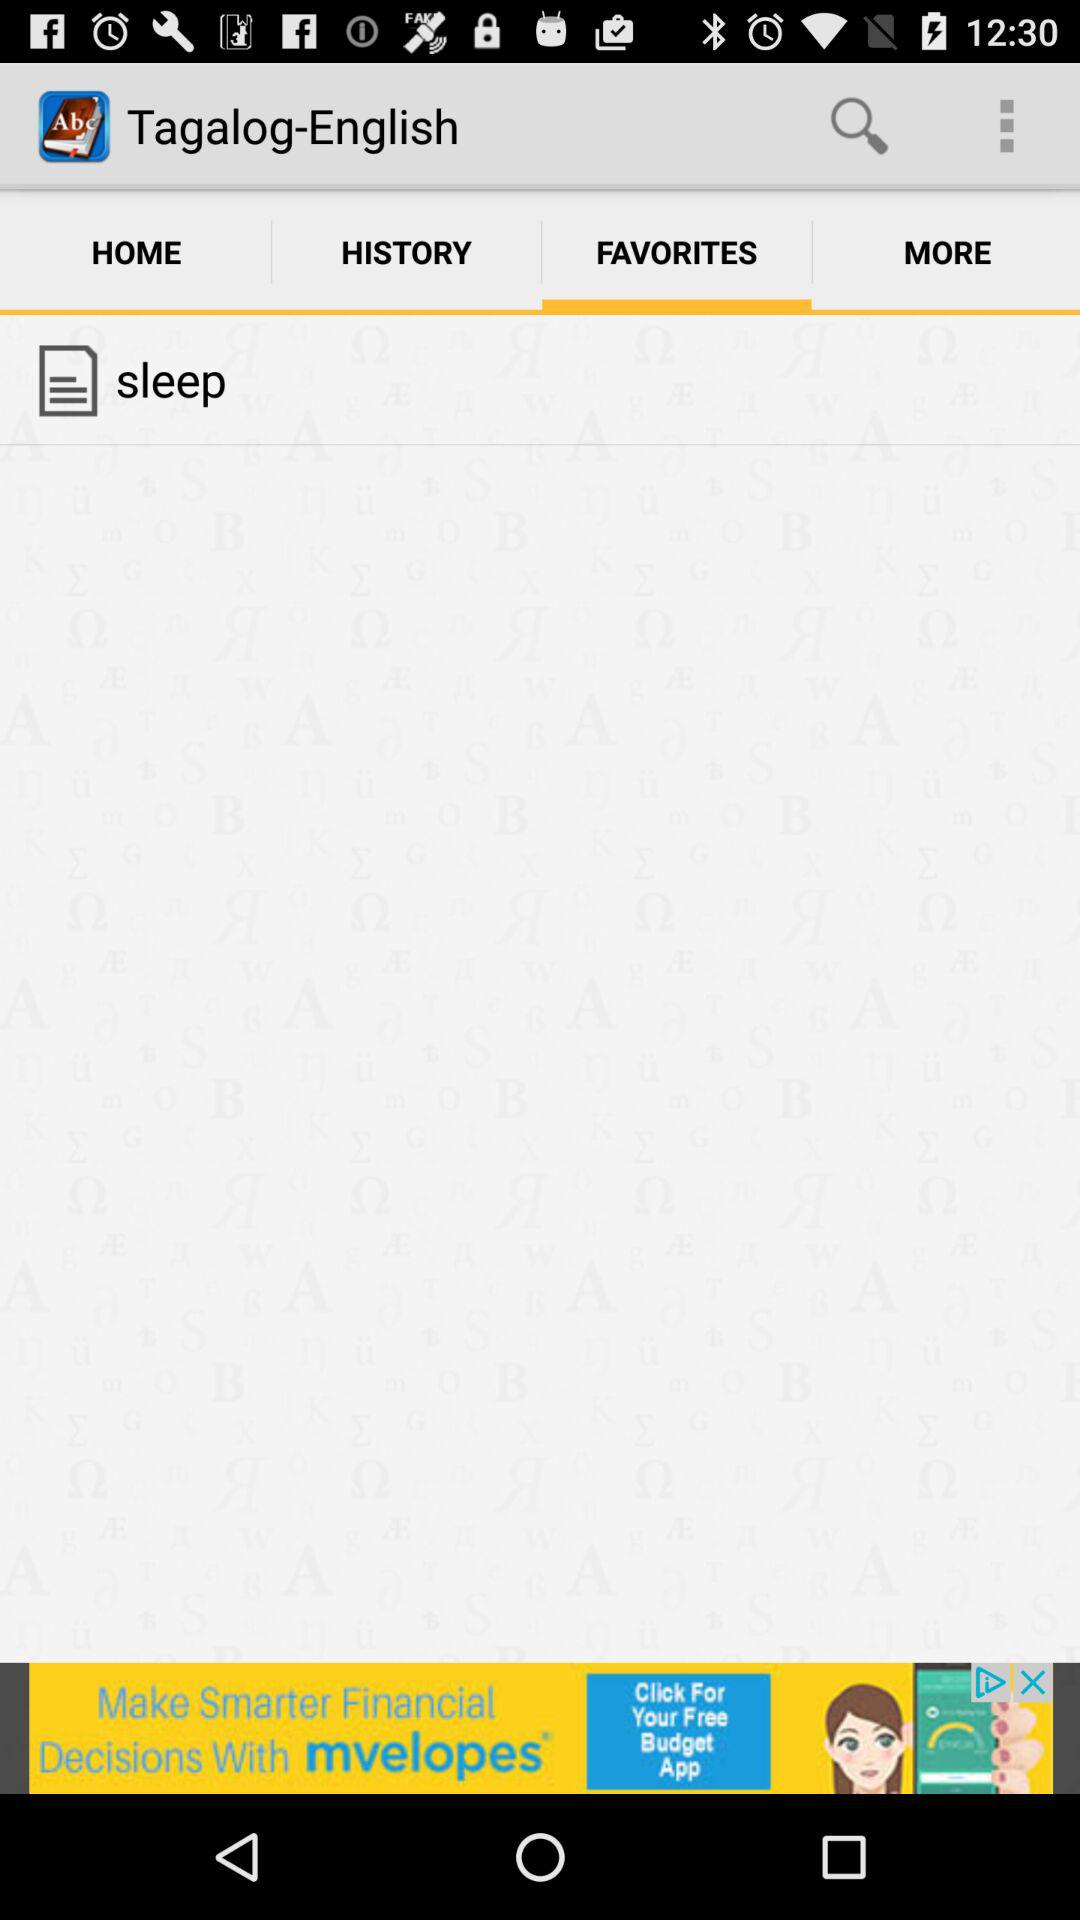Which tab is selected in "Taglog-English"? The selected tab is "FAVORITES". 